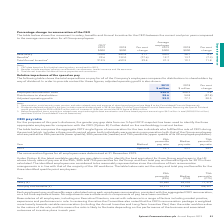According to Spirent Communications Plc's financial document, What do the employee remuneration costs include? Remuneration, social security costs, pension and other related costs and expense of share-based payment. The document states: "Notes 1. Remuneration, social security costs, pension and other related costs and expense of share-based payment (see Note 8 to the Consolidated Finan..." Also, What do the distributions to shareholders include? Dividends declared and paid in the year include a special dividend paid in 2018. The document states: "e 8 to the Consolidated Financial Statements). 2. Dividends declared and paid in the year include a special dividend paid in 2018 (see Note 12 of the ..." Also, What are the components in the table showing the total expenditure on pay for all of the Company’s employees compared to distributions to shareholders by way of dividend? The document contains multiple relevant values: Employee remuneration costs, Distributions to shareholders, Adjusted operating profit. From the document: "Employee remuneration costs 1 220.5 208.9 5.6 Distributions to shareholders 2 28.6 54.8 (47.8) Adjusted operating profit 3 92.9 ay for all of the Comp..." Additionally, In which year was the amount of adjusted operating profit larger? According to the financial document, 2019. The relevant text states: "2019 $000 2018 $000 Per cent change..." Also, can you calculate: What was the change in adjusted operating profit? Based on the calculation: 92.9-77.1, the result is 15.8 (in millions). This is based on the information: "rs 2 28.6 54.8 (47.8) Adjusted operating profit 3 92.9 77.1 20.5 28.6 54.8 (47.8) Adjusted operating profit 3 92.9 77.1 20.5..." The key data points involved are: 77.1, 92.9. Also, can you calculate: What was the average amount of adjusted operating profit recorded across 2018 and 2019? To answer this question, I need to perform calculations using the financial data. The calculation is: (92.9+77.1)/2, which equals 85 (in millions). This is based on the information: "rs 2 28.6 54.8 (47.8) Adjusted operating profit 3 92.9 77.1 20.5 28.6 54.8 (47.8) Adjusted operating profit 3 92.9 77.1 20.5..." The key data points involved are: 77.1, 92.9. 